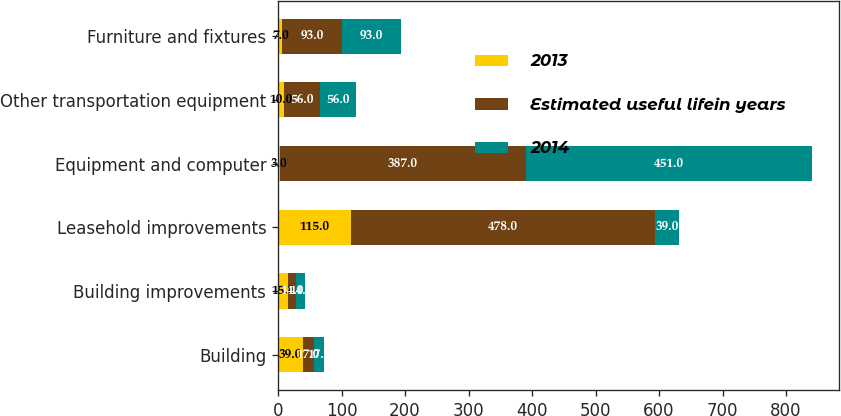Convert chart to OTSL. <chart><loc_0><loc_0><loc_500><loc_500><stacked_bar_chart><ecel><fcel>Building<fcel>Building improvements<fcel>Leasehold improvements<fcel>Equipment and computer<fcel>Other transportation equipment<fcel>Furniture and fixtures<nl><fcel>2013<fcel>39<fcel>15<fcel>115<fcel>3<fcel>10<fcel>7<nl><fcel>Estimated useful lifein years<fcel>17<fcel>14<fcel>478<fcel>387<fcel>56<fcel>93<nl><fcel>2014<fcel>17<fcel>14<fcel>39<fcel>451<fcel>56<fcel>93<nl></chart> 